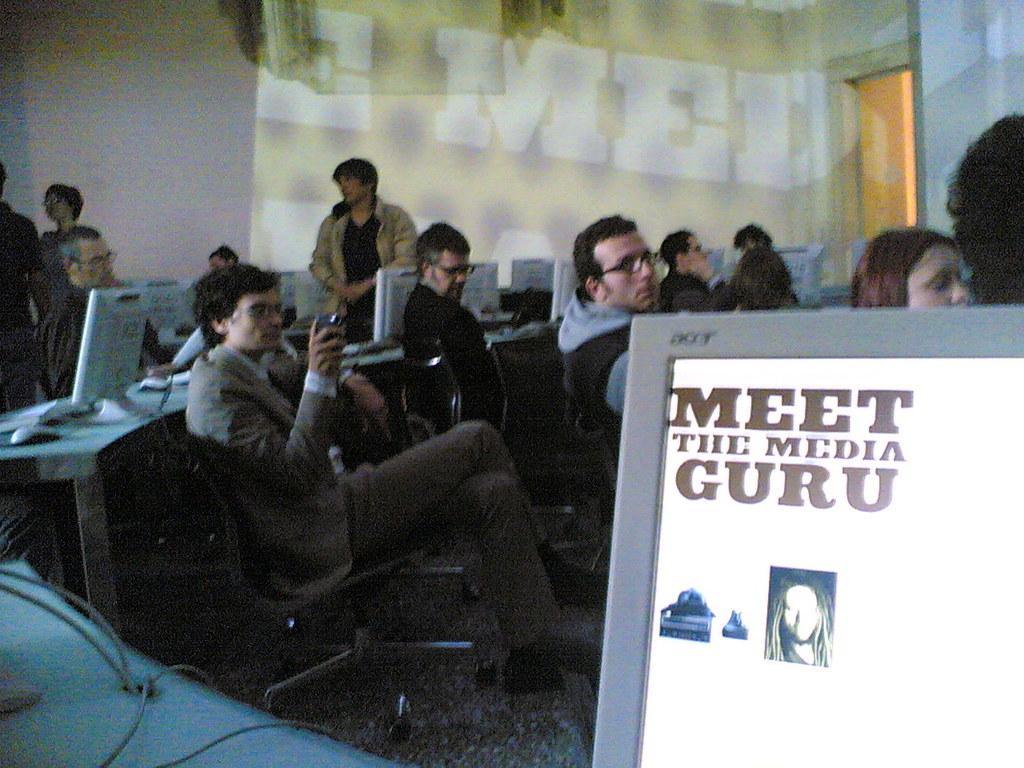In one or two sentences, can you explain what this image depicts? In this image we can see some persons, chairs, monitors and other objects. In the background of the image there is a wall, door and other objects. On the left side of the image there are wires and an object. On the right side of the image there is the monitor. 